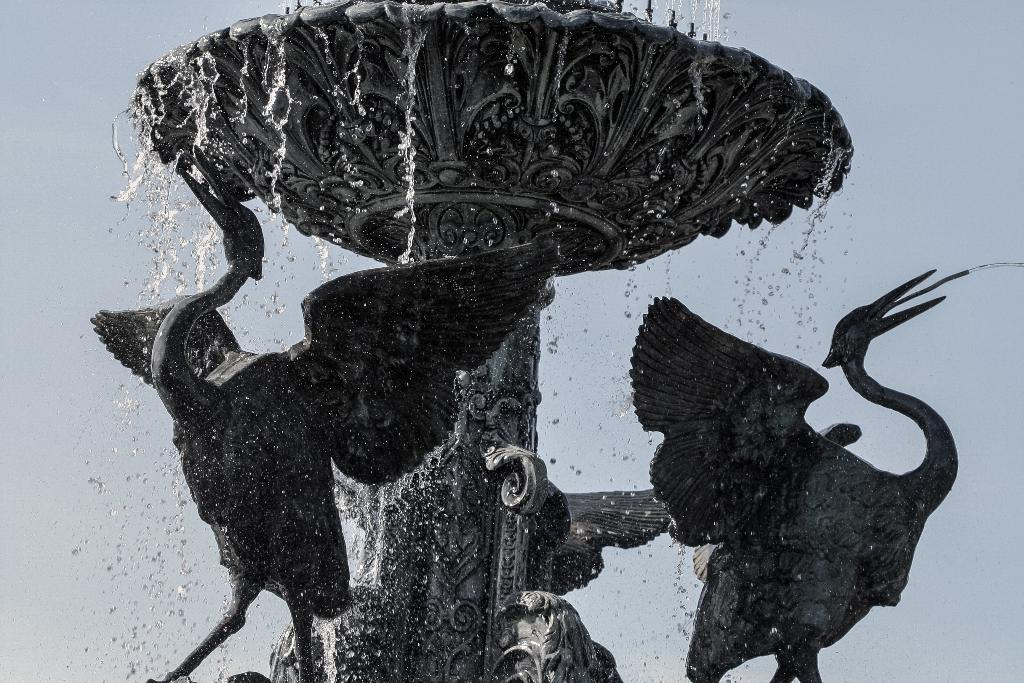What is the main feature in the image? There is a water fountain in the image. Are there any other objects or features near the water fountain? Yes, there are bird statues in the image. What can be seen in the background of the image? The sky is visible in the background of the image. Where is the hammer being used in the image? There is no hammer present in the image. What type of plants can be seen growing near the water fountain? There is no mention of plants in the image; it only features a water fountain and bird statues. 